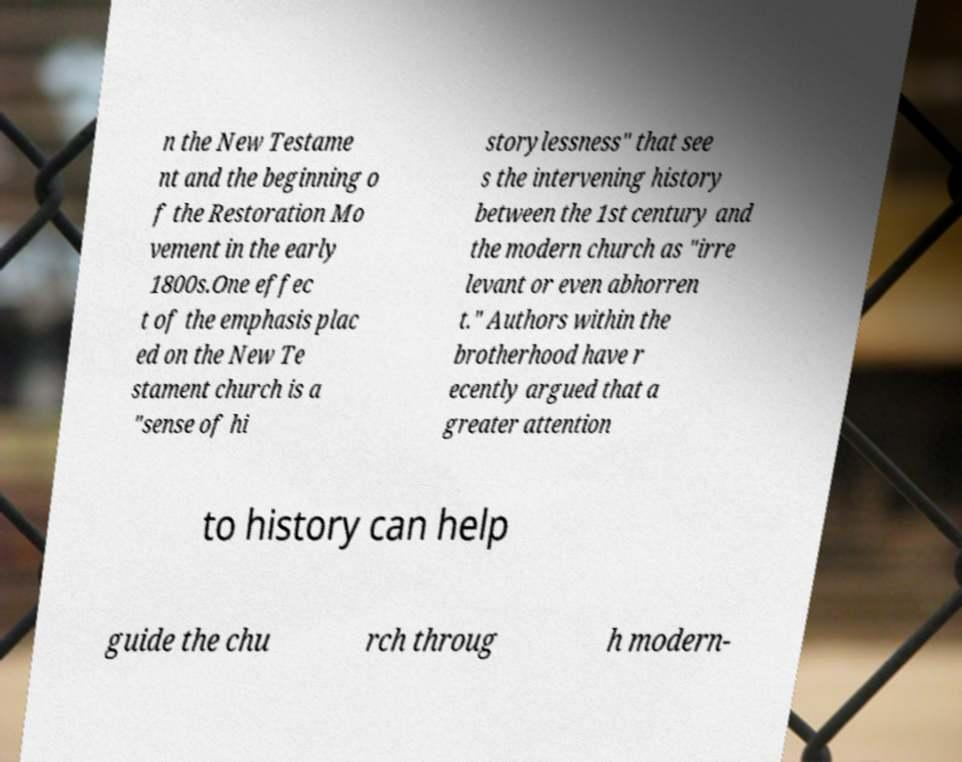Please read and relay the text visible in this image. What does it say? n the New Testame nt and the beginning o f the Restoration Mo vement in the early 1800s.One effec t of the emphasis plac ed on the New Te stament church is a "sense of hi storylessness" that see s the intervening history between the 1st century and the modern church as "irre levant or even abhorren t." Authors within the brotherhood have r ecently argued that a greater attention to history can help guide the chu rch throug h modern- 